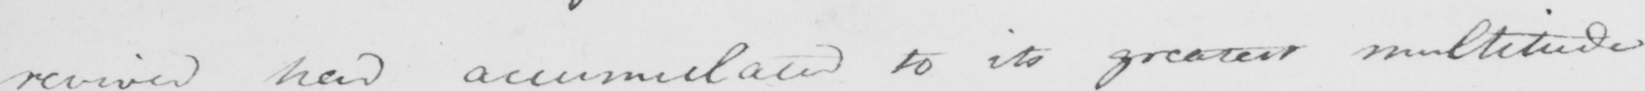Transcribe the text shown in this historical manuscript line. revived had accumulated to its greatest multitude 